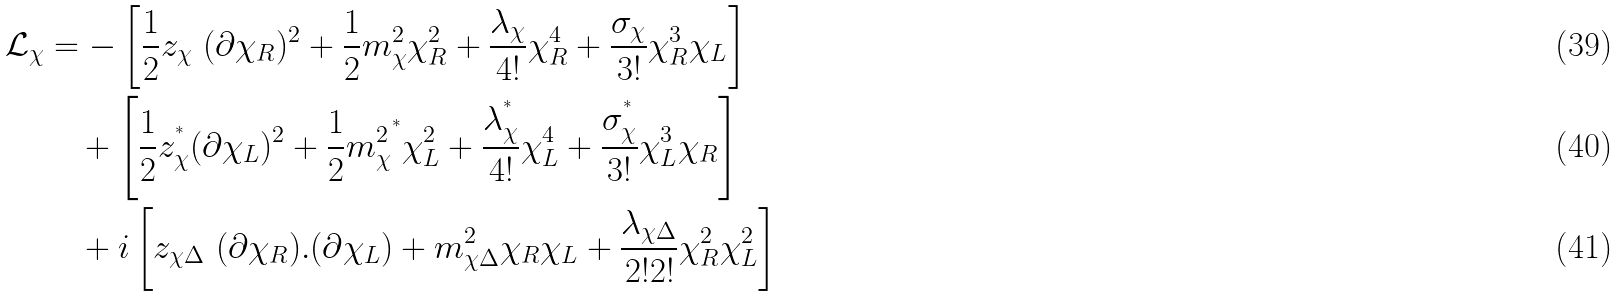<formula> <loc_0><loc_0><loc_500><loc_500>\mathcal { L } _ { \chi } & = - \left [ \frac { 1 } { 2 } z _ { \chi } \ ( \partial \chi _ { R } ) ^ { 2 } + \frac { 1 } { 2 } m _ { \chi } ^ { 2 } \chi _ { R } ^ { 2 } + \frac { \lambda _ { \chi } } { 4 ! } \chi _ { R } ^ { 4 } + \frac { \sigma _ { \chi } } { 3 ! } \chi _ { R } ^ { 3 } \chi _ { L } \right ] \\ & \quad + \left [ \frac { 1 } { 2 } z _ { \chi } ^ { ^ { * } } ( \partial \chi _ { L } ) ^ { 2 } + \frac { 1 } { 2 } { m _ { \chi } ^ { 2 } } ^ { ^ { * } } \chi _ { L } ^ { 2 } + \frac { \lambda _ { \chi } ^ { ^ { * } } } { 4 ! } \chi _ { L } ^ { 4 } + \frac { \sigma _ { \chi } ^ { ^ { * } } } { 3 ! } \chi _ { L } ^ { 3 } \chi _ { R } \right ] \\ & \quad + i \left [ z _ { \chi \Delta } \ ( \partial \chi _ { R } ) . ( \partial \chi _ { L } ) + m ^ { 2 } _ { \chi \Delta } \chi _ { R } \chi _ { L } + \frac { { \lambda _ { \chi \Delta } } } { 2 ! 2 ! } \chi _ { R } ^ { 2 } \chi _ { L } ^ { 2 } \right ]</formula> 